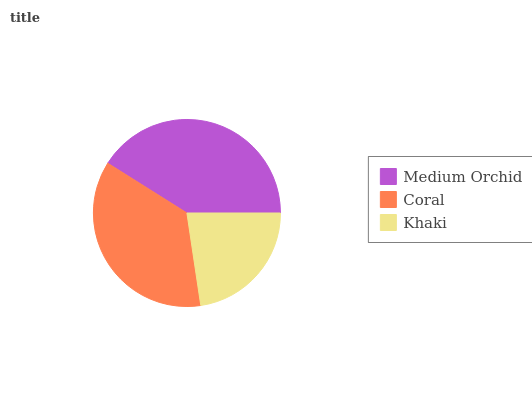Is Khaki the minimum?
Answer yes or no. Yes. Is Medium Orchid the maximum?
Answer yes or no. Yes. Is Coral the minimum?
Answer yes or no. No. Is Coral the maximum?
Answer yes or no. No. Is Medium Orchid greater than Coral?
Answer yes or no. Yes. Is Coral less than Medium Orchid?
Answer yes or no. Yes. Is Coral greater than Medium Orchid?
Answer yes or no. No. Is Medium Orchid less than Coral?
Answer yes or no. No. Is Coral the high median?
Answer yes or no. Yes. Is Coral the low median?
Answer yes or no. Yes. Is Khaki the high median?
Answer yes or no. No. Is Medium Orchid the low median?
Answer yes or no. No. 